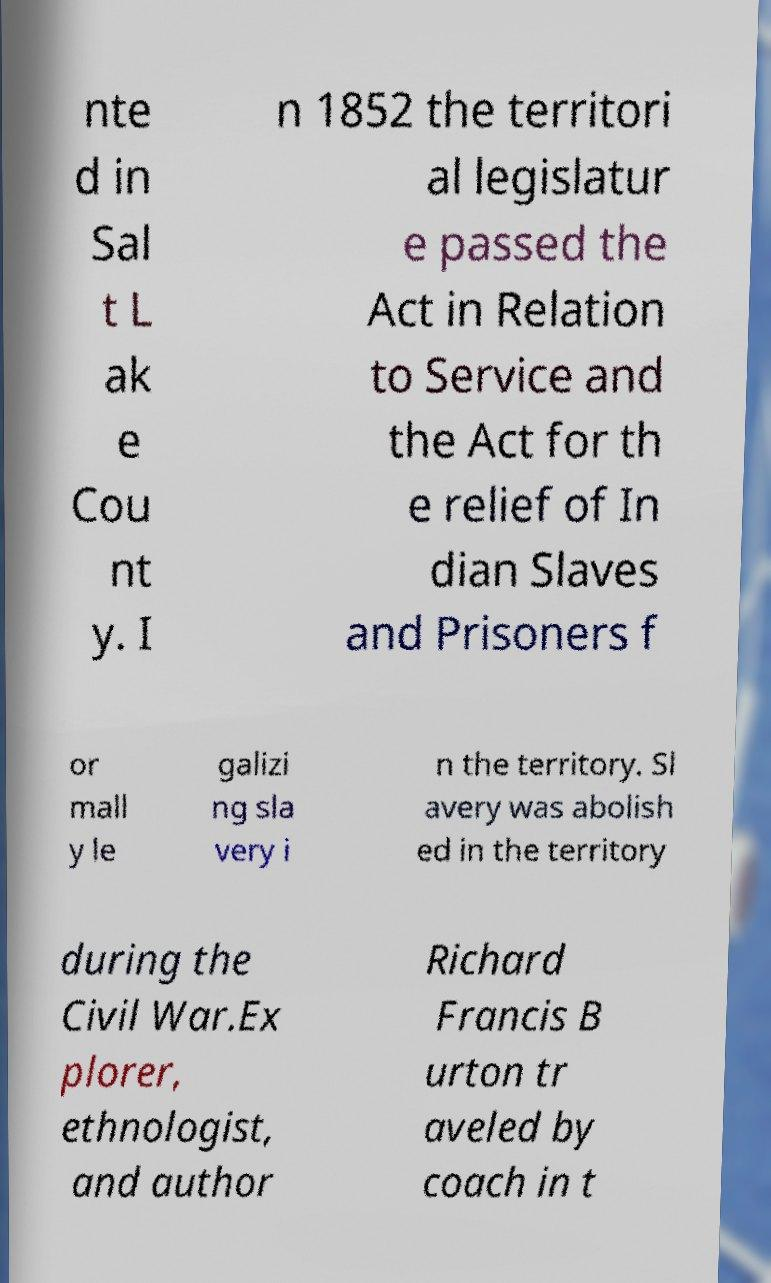For documentation purposes, I need the text within this image transcribed. Could you provide that? nte d in Sal t L ak e Cou nt y. I n 1852 the territori al legislatur e passed the Act in Relation to Service and the Act for th e relief of In dian Slaves and Prisoners f or mall y le galizi ng sla very i n the territory. Sl avery was abolish ed in the territory during the Civil War.Ex plorer, ethnologist, and author Richard Francis B urton tr aveled by coach in t 